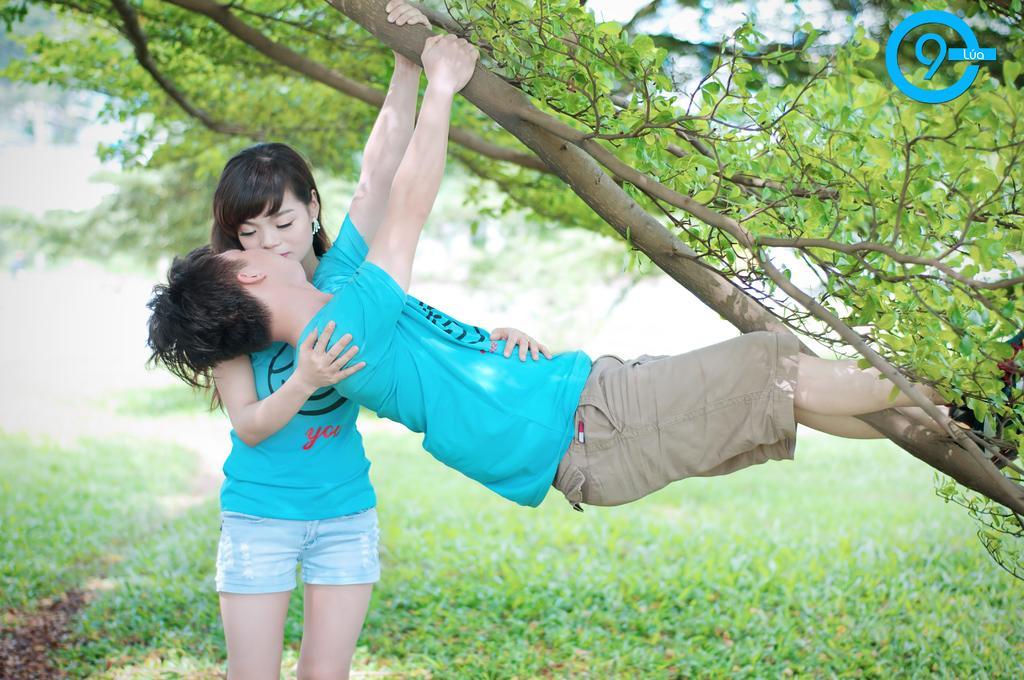In one or two sentences, can you explain what this image depicts? This image is taken outdoors. At the bottom of the image there is a ground with grass on it. On the right side of the image there is a tree. In the middle of the image there is a girl and there is a boy and he is holding a branch. 